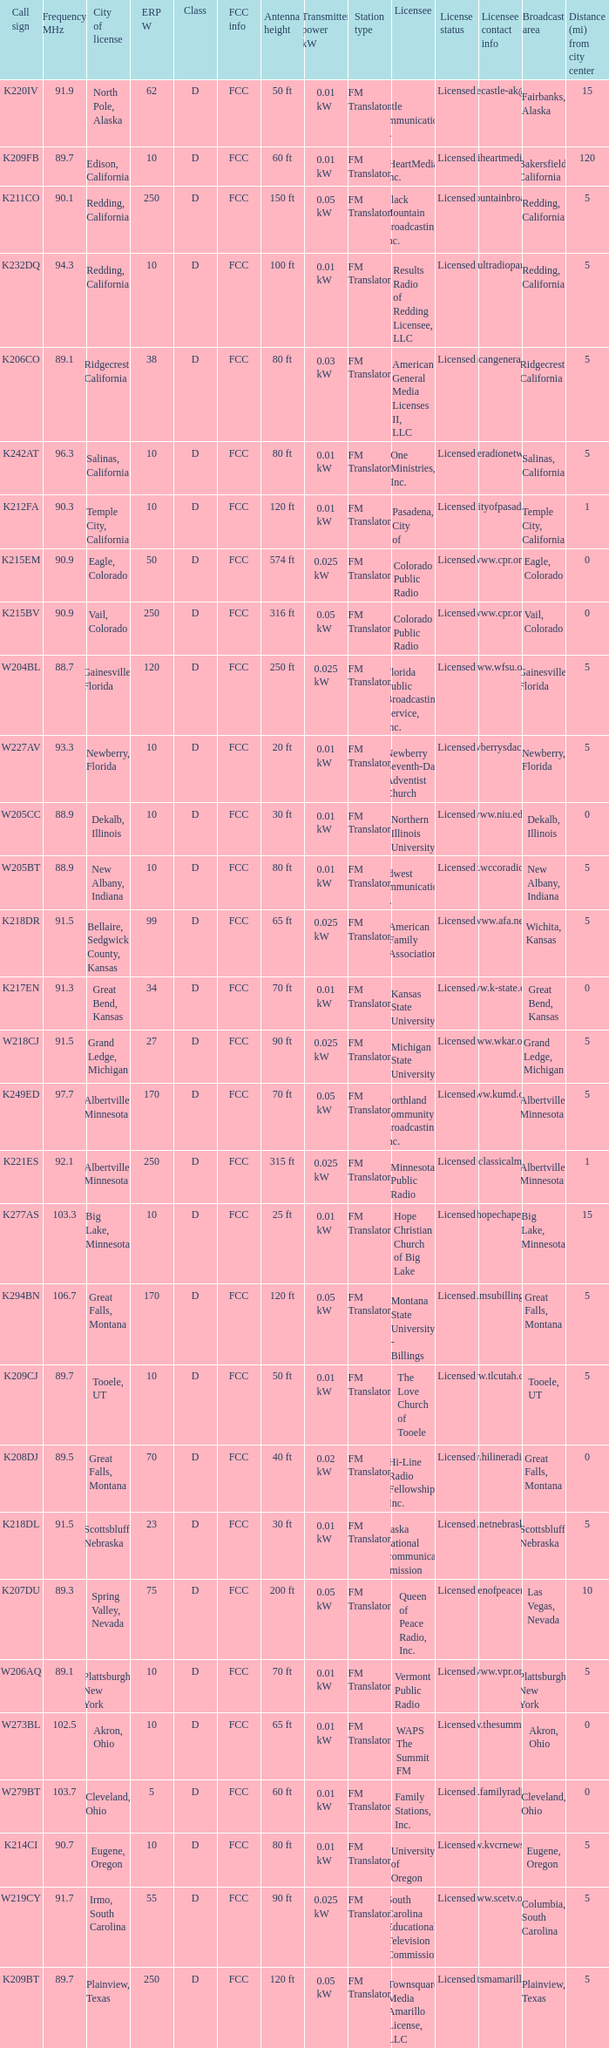What is the class of the translator with 10 ERP W and a call sign of w273bl? D. 